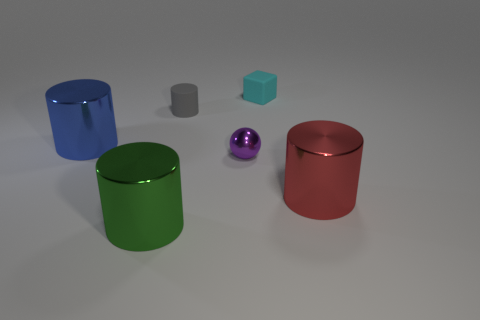There is a block that is the same size as the purple ball; what is its color?
Provide a short and direct response. Cyan. Do the cyan rubber block and the gray rubber object have the same size?
Your answer should be very brief. Yes. There is a cyan rubber block; how many cylinders are on the left side of it?
Offer a terse response. 3. What number of things are either big cylinders that are on the left side of the gray matte thing or tiny purple spheres?
Your answer should be compact. 3. Are there more large red shiny things that are in front of the tiny cylinder than large green shiny objects on the right side of the small purple sphere?
Make the answer very short. Yes. There is a red cylinder; is it the same size as the cylinder behind the large blue cylinder?
Keep it short and to the point. No. How many blocks are either purple objects or big green metallic things?
Give a very brief answer. 0. What is the size of the cyan object that is made of the same material as the small gray cylinder?
Offer a terse response. Small. Is the size of the metal cylinder that is behind the tiny metal ball the same as the matte thing that is on the right side of the small gray matte object?
Your answer should be very brief. No. What number of things are either large blocks or green things?
Provide a short and direct response. 1. 